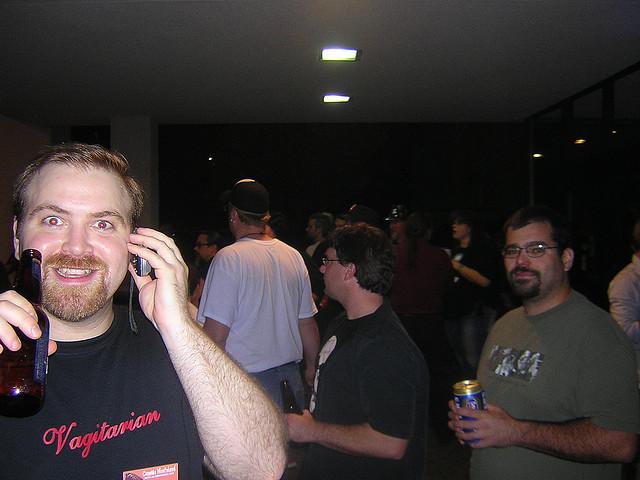What are people drinking?
Keep it brief. Beer. What is the closest man holding in his left hand?
Short answer required. Phone. Is it a crowded room?
Keep it brief. Yes. 